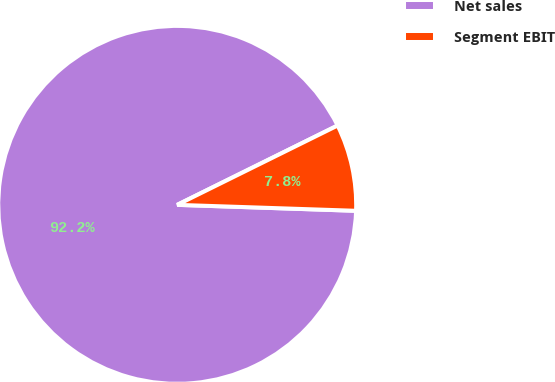<chart> <loc_0><loc_0><loc_500><loc_500><pie_chart><fcel>Net sales<fcel>Segment EBIT<nl><fcel>92.16%<fcel>7.84%<nl></chart> 